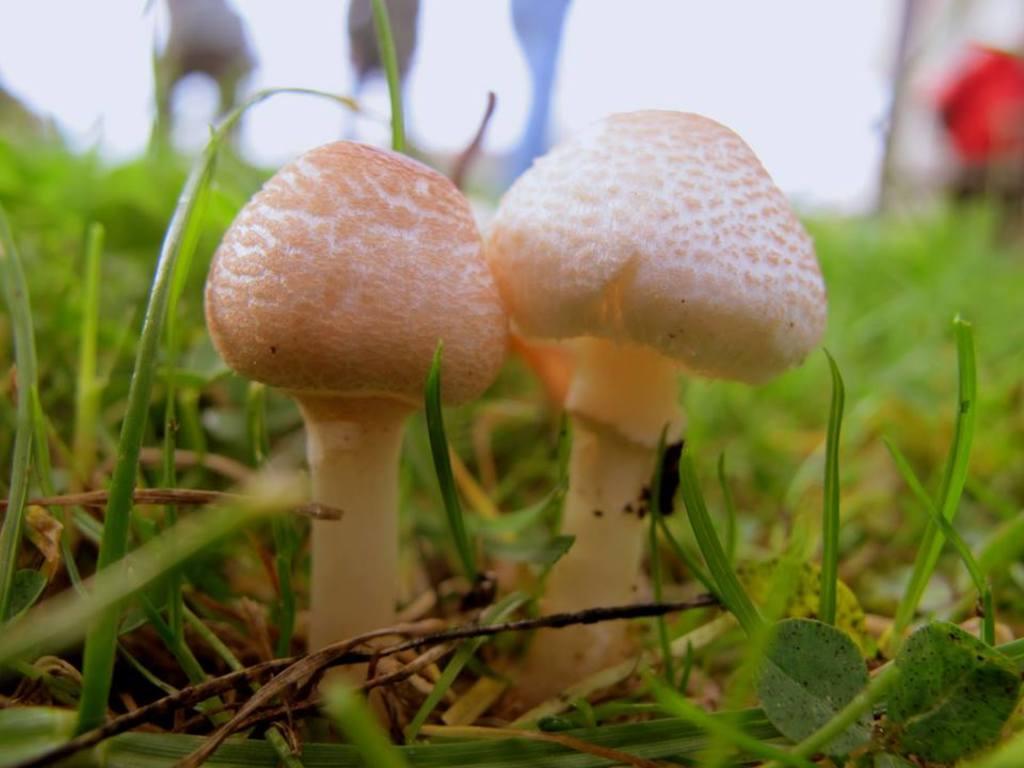In one or two sentences, can you explain what this image depicts? In the image we can see there are two mushroom cream in color. This is a grass and the background is blurred. 